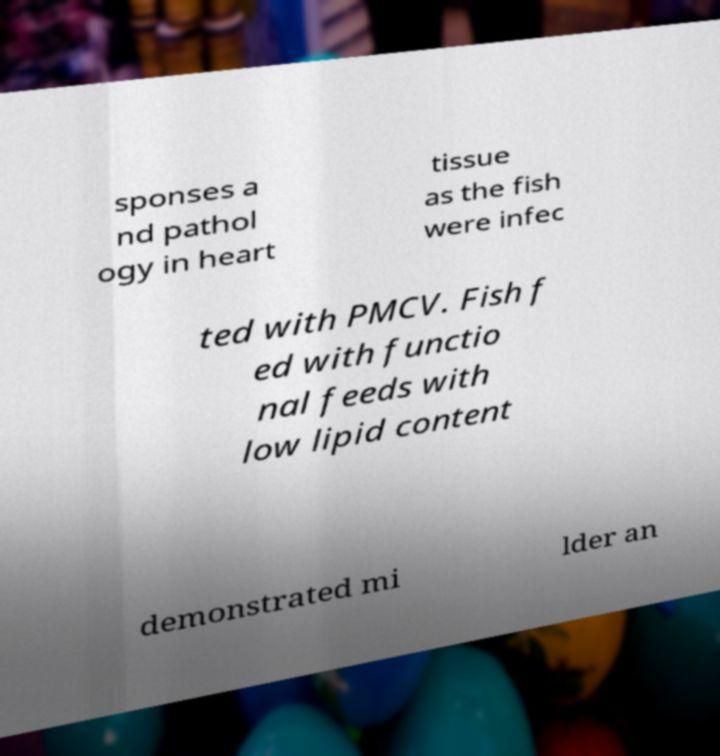Can you accurately transcribe the text from the provided image for me? sponses a nd pathol ogy in heart tissue as the fish were infec ted with PMCV. Fish f ed with functio nal feeds with low lipid content demonstrated mi lder an 